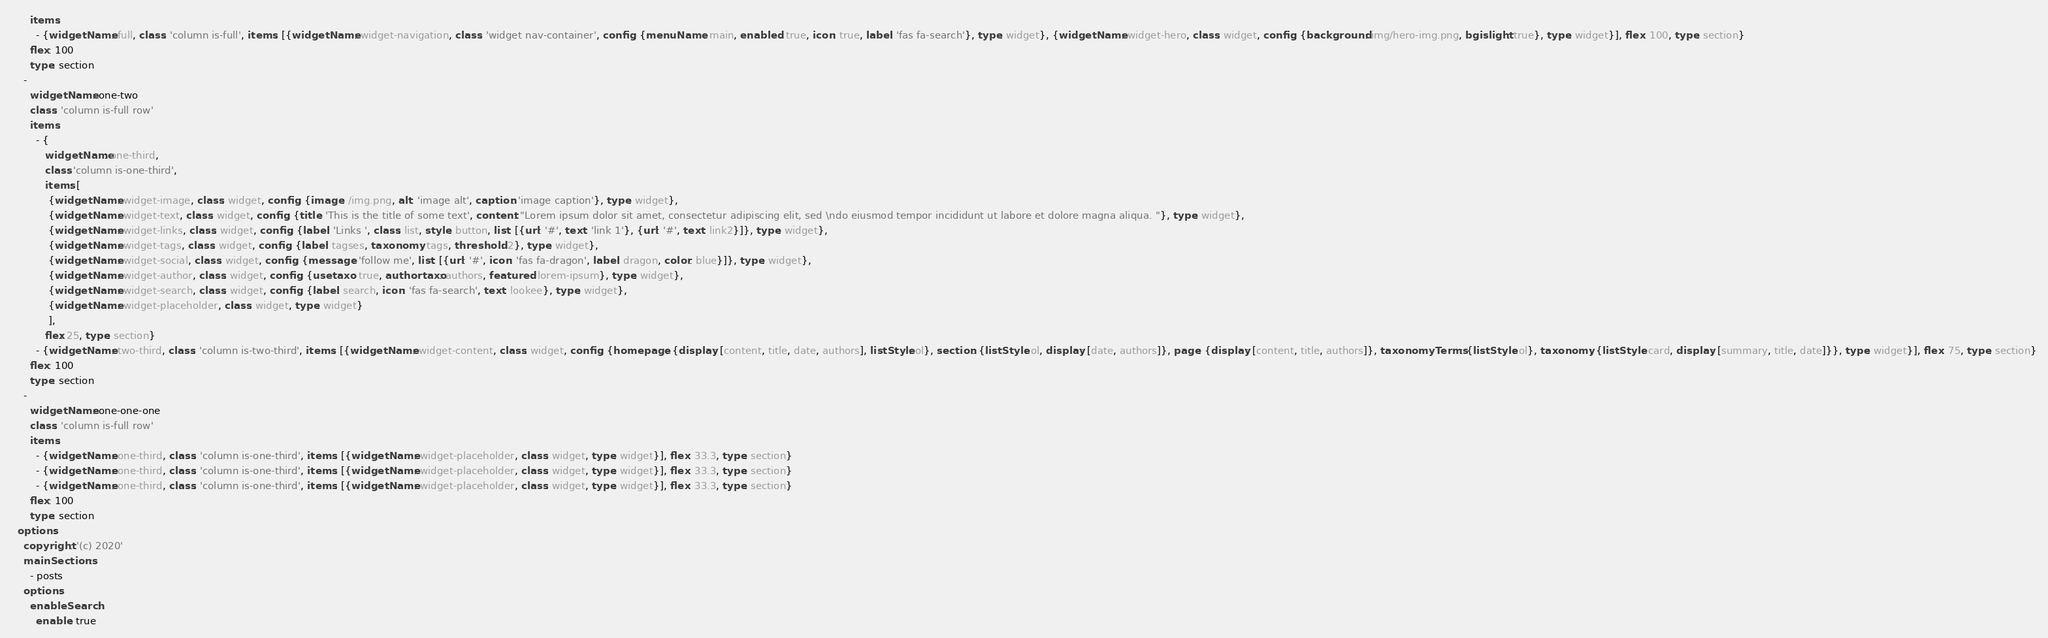<code> <loc_0><loc_0><loc_500><loc_500><_YAML_>      items:
        - {widgetName: full, class: 'column is-full', items: [{widgetName: widget-navigation, class: 'widget nav-container', config: {menuName: main, enabled: true, icon: true, label: 'fas fa-search'}, type: widget}, {widgetName: widget-hero, class: widget, config: {background: img/hero-img.png, bgislight: true}, type: widget}], flex: 100, type: section}
      flex: 100
      type: section
    -
      widgetName: one-two
      class: 'column is-full row'
      items:
        - {
          widgetName: one-third, 
          class: 'column is-one-third', 
          items: [
            {widgetName: widget-image, class: widget, config: {image: /img.png, alt: 'image alt', caption: 'image caption'}, type: widget},
            {widgetName: widget-text, class: widget, config: {title: 'This is the title of some text', content: "Lorem ipsum dolor sit amet, consectetur adipiscing elit, sed \ndo eiusmod tempor incididunt ut labore et dolore magna aliqua. "}, type: widget}, 
            {widgetName: widget-links, class: widget, config: {label: 'Links ', class: list, style: button, list: [{url: '#', text: 'link 1'}, {url: '#', text: link2}]}, type: widget}, 
            {widgetName: widget-tags, class: widget, config: {label: tagses, taxonomy: tags, threshold: 2}, type: widget}, 
            {widgetName: widget-social, class: widget, config: {message: 'follow me', list: [{url: '#', icon: 'fas fa-dragon', label: dragon, color: blue}]}, type: widget}, 
            {widgetName: widget-author, class: widget, config: {usetaxo: true, authortaxo: authors, featured: lorem-ipsum}, type: widget}, 
            {widgetName: widget-search, class: widget, config: {label: search, icon: 'fas fa-search', text: lookee}, type: widget}, 
            {widgetName: widget-placeholder, class: widget, type: widget}
            ], 
          flex: 25, type: section}
        - {widgetName: two-third, class: 'column is-two-third', items: [{widgetName: widget-content, class: widget, config: {homepage: {display: [content, title, date, authors], listStyle: ol}, section: {listStyle: ol, display: [date, authors]}, page: {display: [content, title, authors]}, taxonomyTerms: {listStyle: ol}, taxonomy: {listStyle: card, display: [summary, title, date]}}, type: widget}], flex: 75, type: section}
      flex: 100
      type: section
    -
      widgetName: one-one-one
      class: 'column is-full row'
      items:
        - {widgetName: one-third, class: 'column is-one-third', items: [{widgetName: widget-placeholder, class: widget, type: widget}], flex: 33.3, type: section}
        - {widgetName: one-third, class: 'column is-one-third', items: [{widgetName: widget-placeholder, class: widget, type: widget}], flex: 33.3, type: section}
        - {widgetName: one-third, class: 'column is-one-third', items: [{widgetName: widget-placeholder, class: widget, type: widget}], flex: 33.3, type: section}
      flex: 100
      type: section
  options:
    copyright: '(c) 2020'
    mainSections:
      - posts
    options:
      enableSearch:
        enable: true</code> 